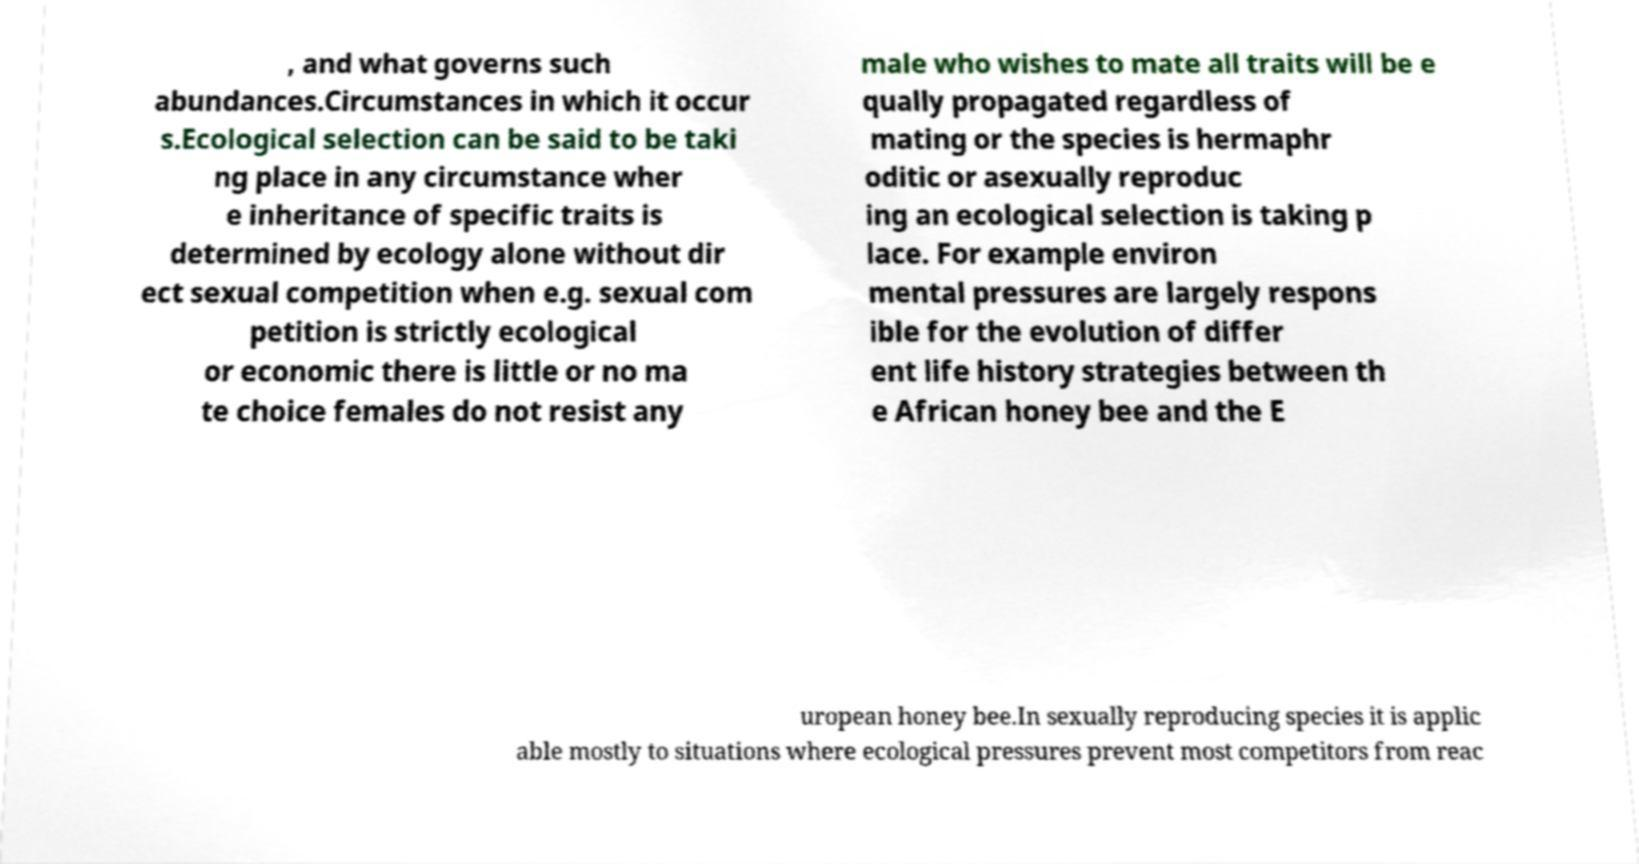Can you read and provide the text displayed in the image?This photo seems to have some interesting text. Can you extract and type it out for me? , and what governs such abundances.Circumstances in which it occur s.Ecological selection can be said to be taki ng place in any circumstance wher e inheritance of specific traits is determined by ecology alone without dir ect sexual competition when e.g. sexual com petition is strictly ecological or economic there is little or no ma te choice females do not resist any male who wishes to mate all traits will be e qually propagated regardless of mating or the species is hermaphr oditic or asexually reproduc ing an ecological selection is taking p lace. For example environ mental pressures are largely respons ible for the evolution of differ ent life history strategies between th e African honey bee and the E uropean honey bee.In sexually reproducing species it is applic able mostly to situations where ecological pressures prevent most competitors from reac 